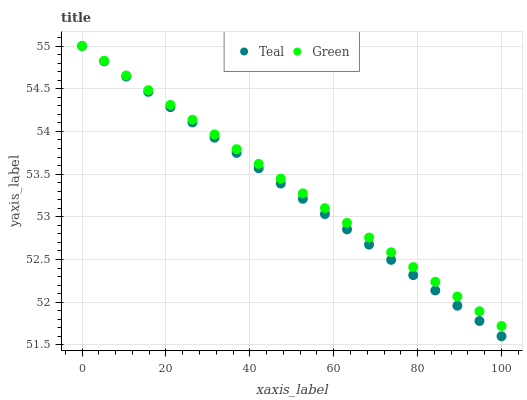Does Teal have the minimum area under the curve?
Answer yes or no. Yes. Does Green have the maximum area under the curve?
Answer yes or no. Yes. Does Teal have the maximum area under the curve?
Answer yes or no. No. Is Teal the smoothest?
Answer yes or no. Yes. Is Green the roughest?
Answer yes or no. Yes. Is Teal the roughest?
Answer yes or no. No. Does Teal have the lowest value?
Answer yes or no. Yes. Does Teal have the highest value?
Answer yes or no. Yes. Does Teal intersect Green?
Answer yes or no. Yes. Is Teal less than Green?
Answer yes or no. No. Is Teal greater than Green?
Answer yes or no. No. 